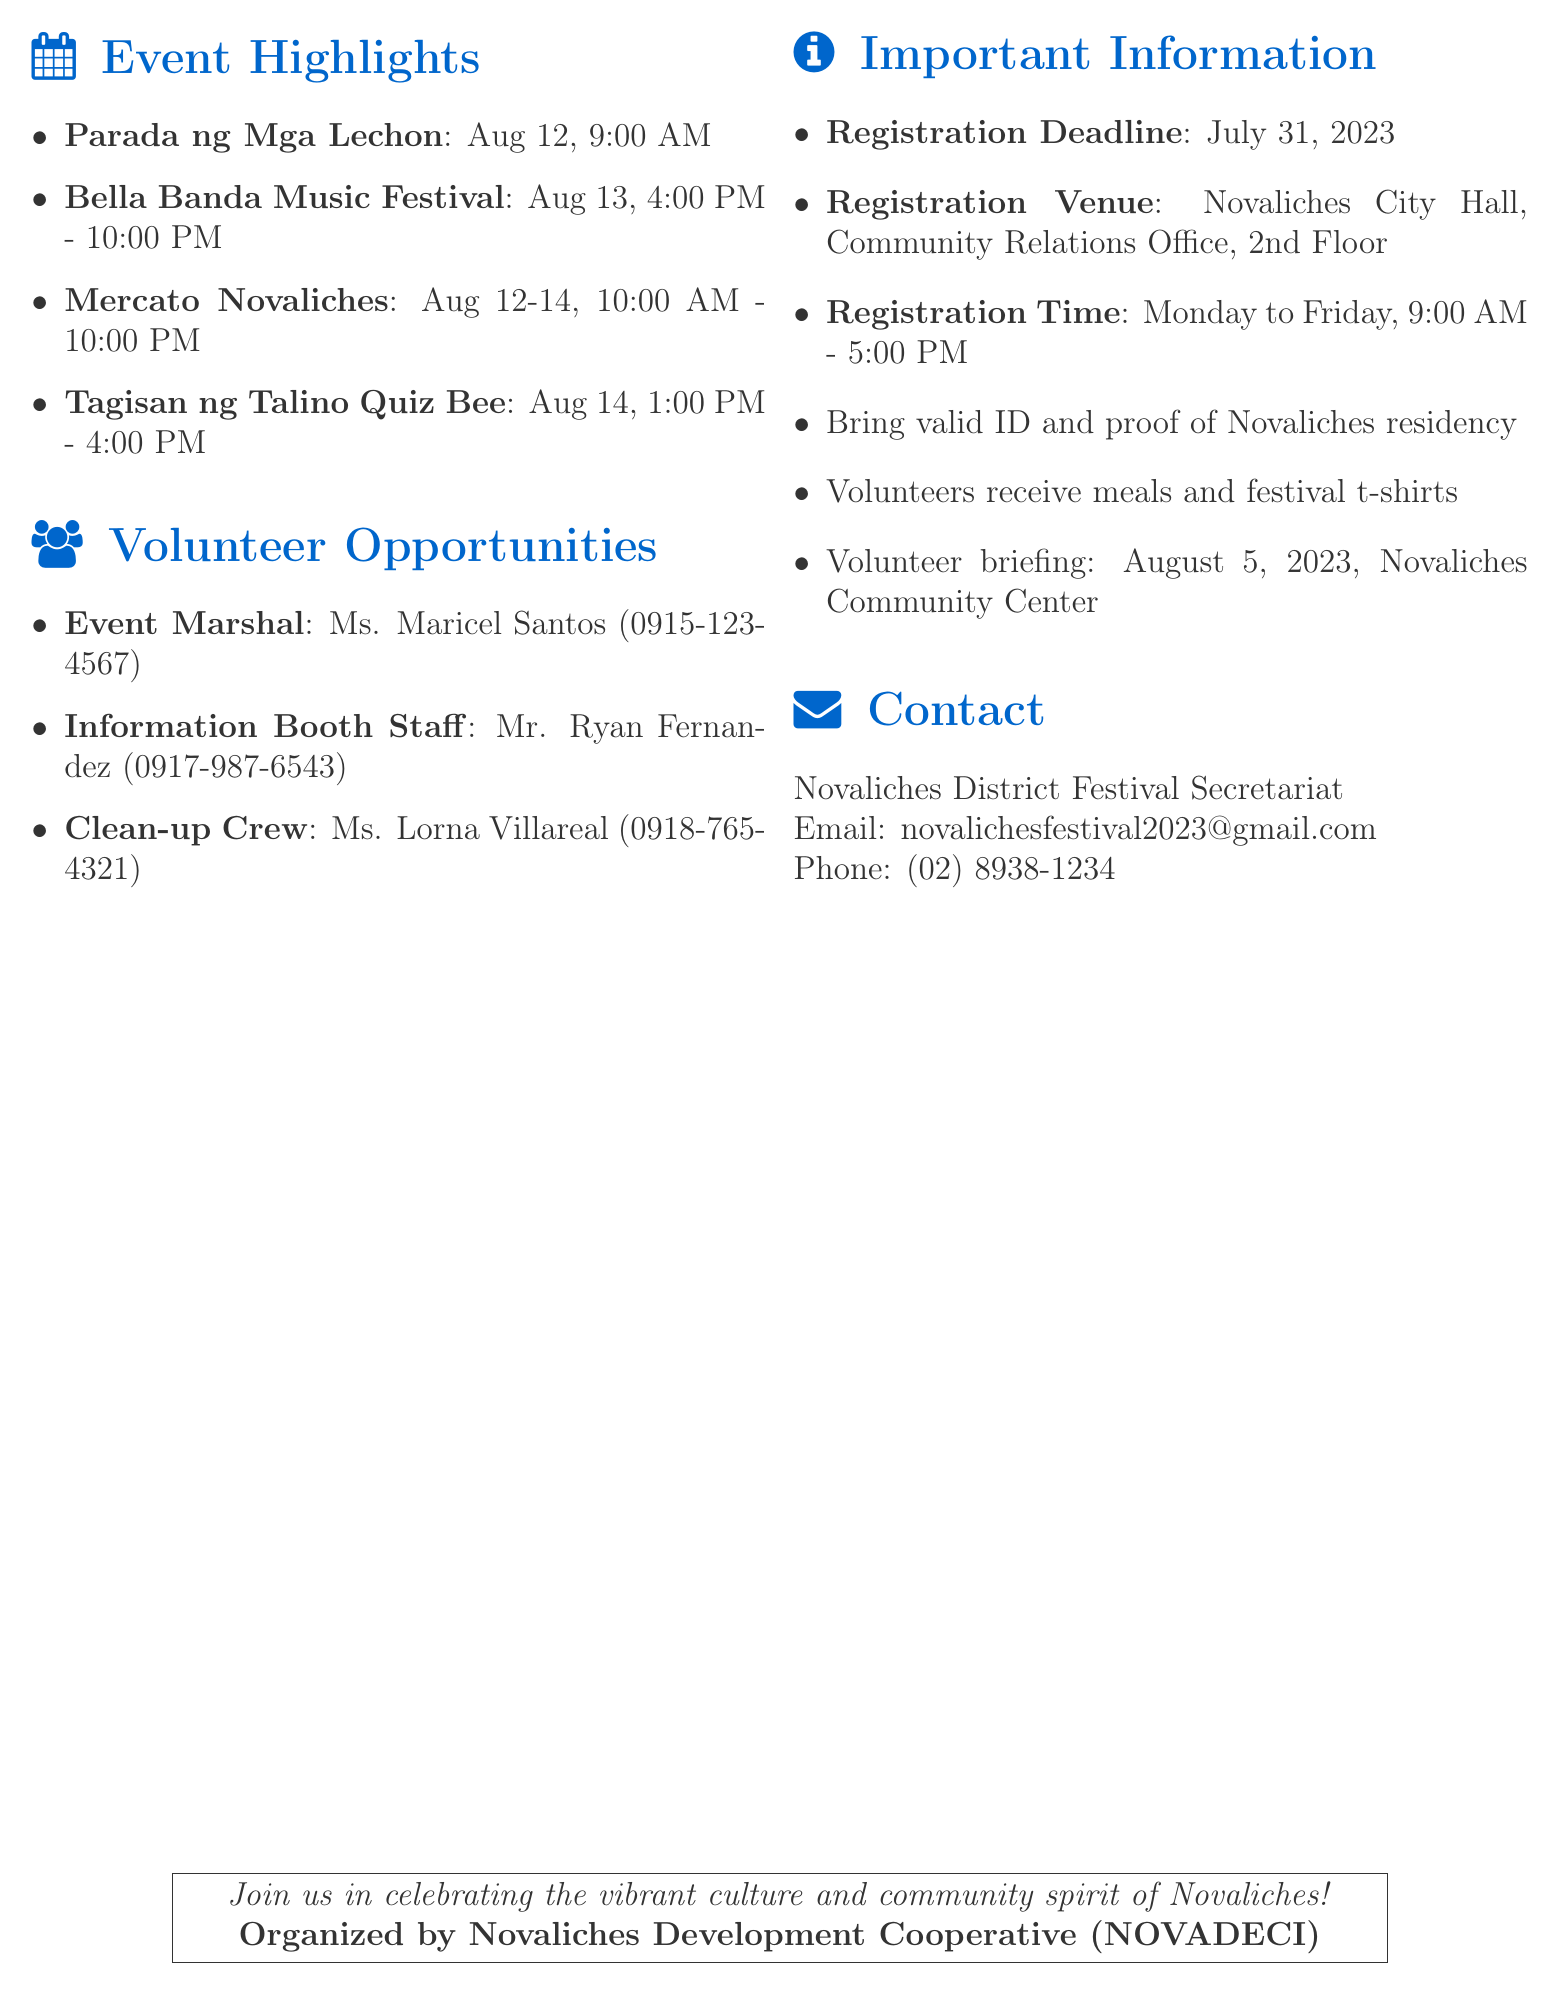What is the event name? The event name is specified at the beginning of the document.
Answer: Novaliches District Festival 2023 When is the festival taking place? The dates for the festival are mentioned in the document.
Answer: August 12-14, 2023 Who is the main organizer of the event? The main organizer is identified in the document under the organizer section.
Answer: Novaliches Development Cooperative (NOVADECI) What is the time for the 'Parada ng Mga Lechon'? The time for this event is listed in the event highlights section.
Answer: August 12, 9:00 AM How many days will 'Mercato Novaliches' be open? The duration of 'Mercato Novaliches' is specified in the highlights.
Answer: Three days Which role requires knowledge of Novaliches history? This information can be found under the volunteer opportunities section.
Answer: Information Booth Staff What do volunteers receive during the festival? The benefits for volunteers are mentioned in the additional information section.
Answer: Meals and festival t-shirts What is the registration deadline? The exact deadline is specified in the important information section.
Answer: July 31, 2023 Where can volunteers register? The registration venue is clearly stated in the document.
Answer: Novaliches City Hall, Community Relations Office, 2nd Floor 